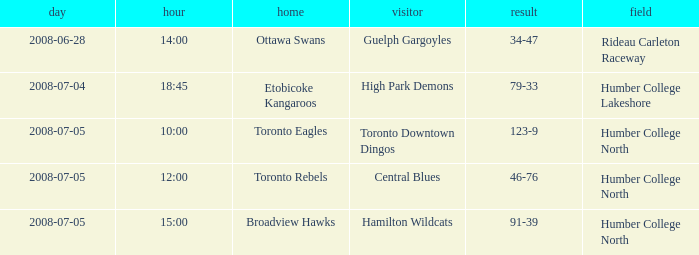What is the Away with a Time that is 14:00? Guelph Gargoyles. 